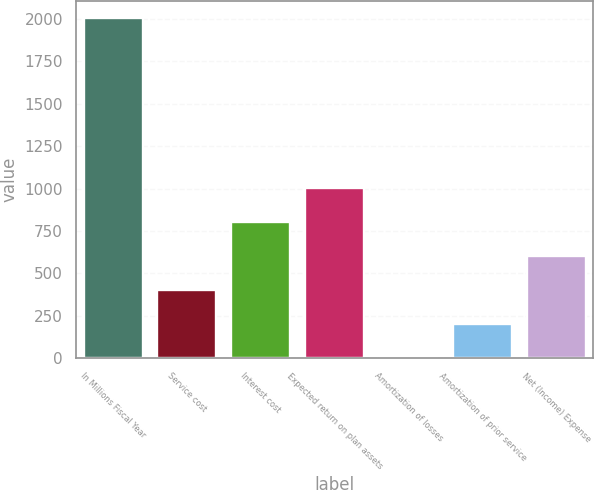Convert chart to OTSL. <chart><loc_0><loc_0><loc_500><loc_500><bar_chart><fcel>In Millions Fiscal Year<fcel>Service cost<fcel>Interest cost<fcel>Expected return on plan assets<fcel>Amortization of losses<fcel>Amortization of prior service<fcel>Net (Income) Expense<nl><fcel>2003<fcel>402.2<fcel>802.4<fcel>1002.5<fcel>2<fcel>202.1<fcel>602.3<nl></chart> 